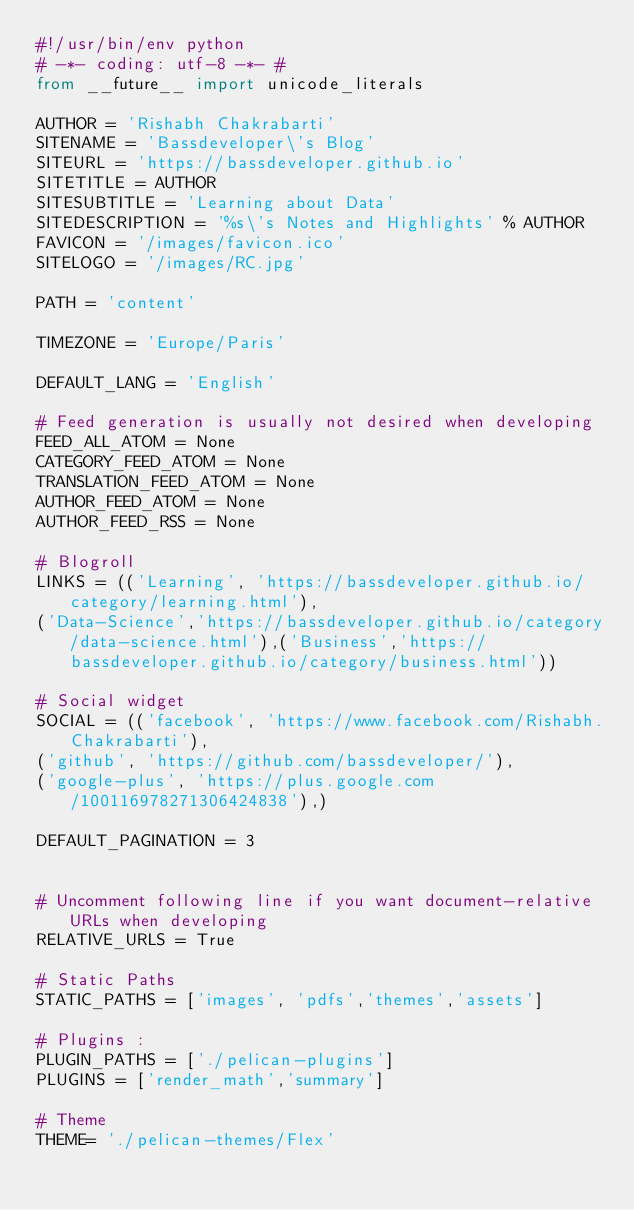<code> <loc_0><loc_0><loc_500><loc_500><_Python_>#!/usr/bin/env python
# -*- coding: utf-8 -*- #
from __future__ import unicode_literals

AUTHOR = 'Rishabh Chakrabarti'
SITENAME = 'Bassdeveloper\'s Blog'
SITEURL = 'https://bassdeveloper.github.io'
SITETITLE = AUTHOR
SITESUBTITLE = 'Learning about Data'
SITEDESCRIPTION = '%s\'s Notes and Highlights' % AUTHOR
FAVICON = '/images/favicon.ico'
SITELOGO = '/images/RC.jpg'

PATH = 'content'

TIMEZONE = 'Europe/Paris'

DEFAULT_LANG = 'English'

# Feed generation is usually not desired when developing
FEED_ALL_ATOM = None
CATEGORY_FEED_ATOM = None
TRANSLATION_FEED_ATOM = None
AUTHOR_FEED_ATOM = None
AUTHOR_FEED_RSS = None

# Blogroll
LINKS = (('Learning', 'https://bassdeveloper.github.io/category/learning.html'),
('Data-Science','https://bassdeveloper.github.io/category/data-science.html'),('Business','https://bassdeveloper.github.io/category/business.html'))

# Social widget
SOCIAL = (('facebook', 'https://www.facebook.com/Rishabh.Chakrabarti'),
('github', 'https://github.com/bassdeveloper/'),
('google-plus', 'https://plus.google.com/100116978271306424838'),)

DEFAULT_PAGINATION = 3


# Uncomment following line if you want document-relative URLs when developing
RELATIVE_URLS = True

# Static Paths
STATIC_PATHS = ['images', 'pdfs','themes','assets']

# Plugins :
PLUGIN_PATHS = ['./pelican-plugins']
PLUGINS = ['render_math','summary']

# Theme
THEME= './pelican-themes/Flex'
</code> 